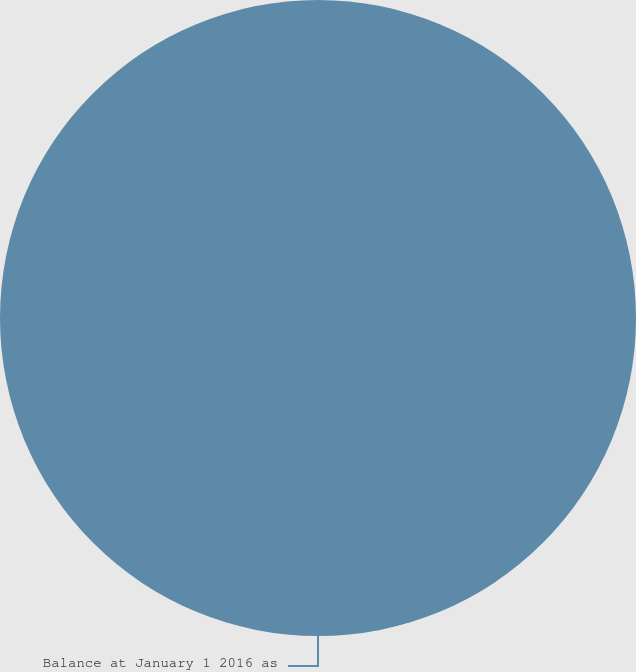<chart> <loc_0><loc_0><loc_500><loc_500><pie_chart><fcel>Balance at January 1 2016 as<nl><fcel>100.0%<nl></chart> 